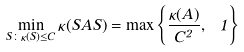<formula> <loc_0><loc_0><loc_500><loc_500>\min _ { S \colon \kappa ( S ) \leq C } \kappa ( S A S ) = \max \left \{ \frac { \kappa ( A ) } { C ^ { 2 } } , \ 1 \right \}</formula> 